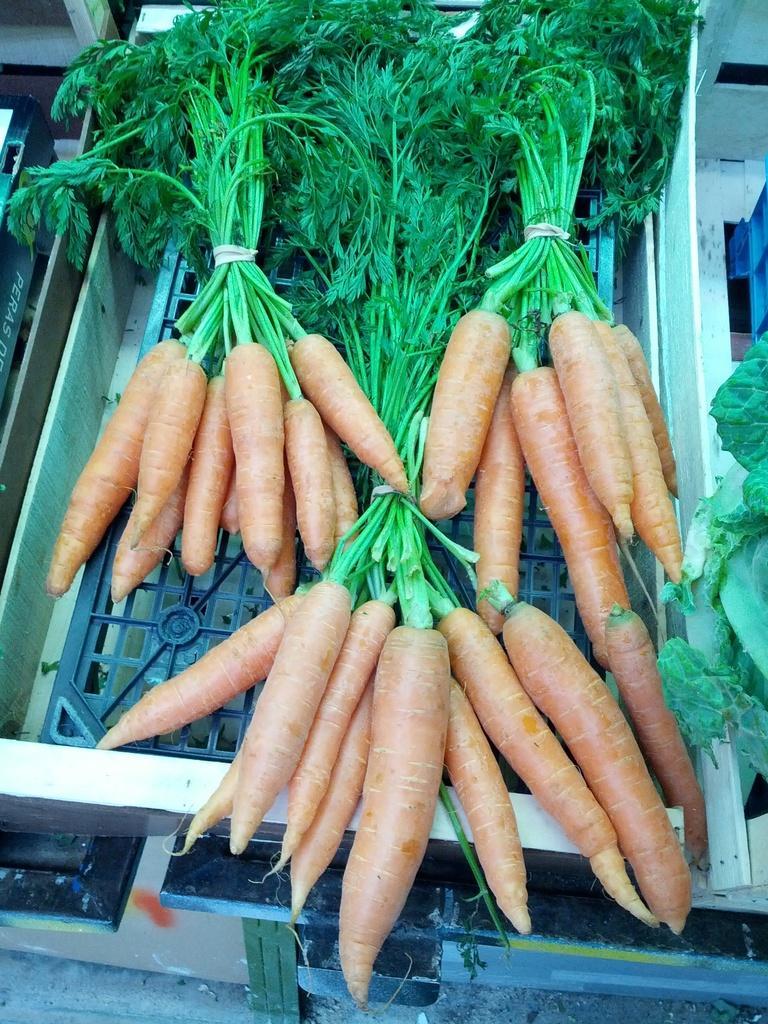Could you give a brief overview of what you see in this image? In the picture I can see the carrots and vegetables on the metal grill plate. 